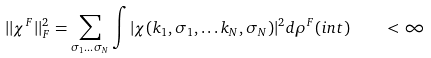Convert formula to latex. <formula><loc_0><loc_0><loc_500><loc_500>| | \chi ^ { F } | | _ { F } ^ { 2 } = \sum _ { \sigma _ { 1 } \dots \sigma _ { N } } \int \nolimits | \chi ( { k } _ { 1 } , \sigma _ { 1 } , \dots { k } _ { N } , \sigma _ { N } ) | ^ { 2 } d \rho ^ { F } ( i n t ) \quad < \infty</formula> 